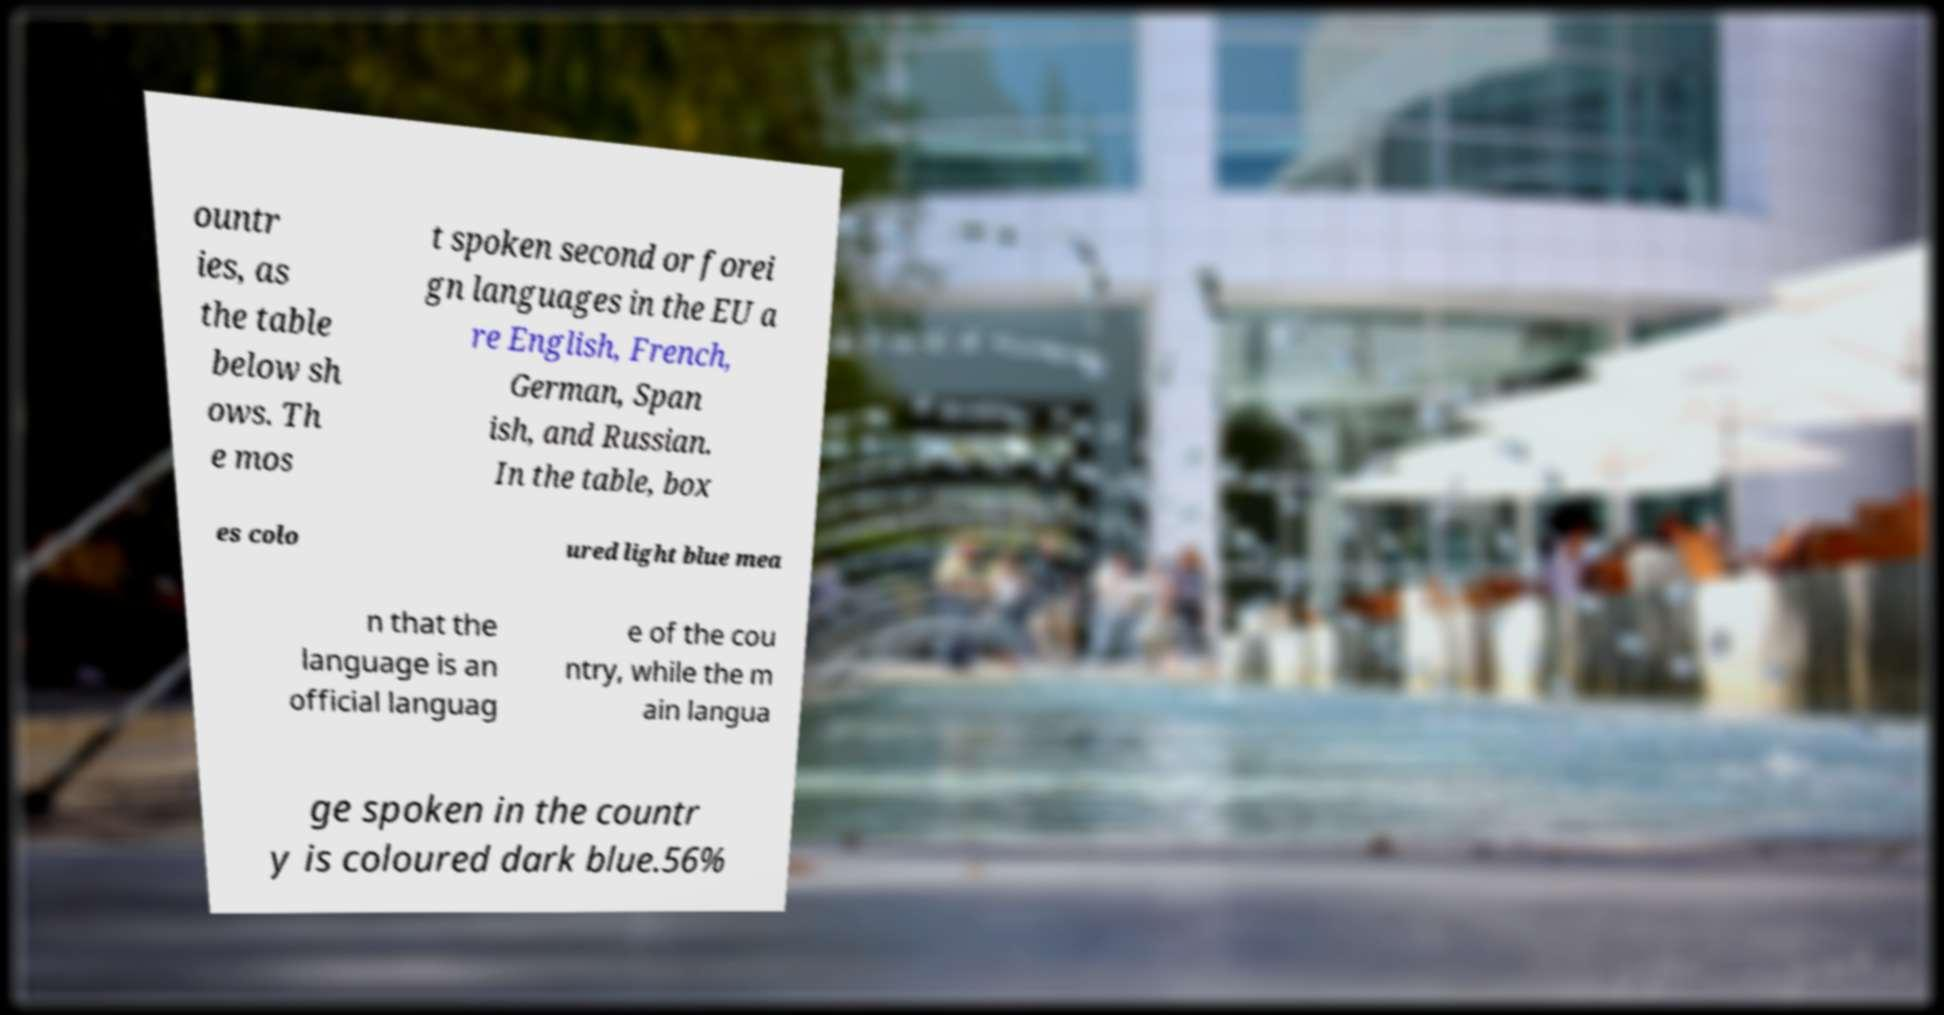For documentation purposes, I need the text within this image transcribed. Could you provide that? ountr ies, as the table below sh ows. Th e mos t spoken second or forei gn languages in the EU a re English, French, German, Span ish, and Russian. In the table, box es colo ured light blue mea n that the language is an official languag e of the cou ntry, while the m ain langua ge spoken in the countr y is coloured dark blue.56% 